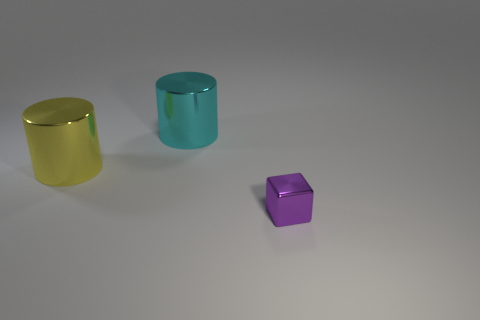The purple metallic block is what size?
Give a very brief answer. Small. There is a object that is on the right side of the cyan thing; what shape is it?
Make the answer very short. Cube. Do the big cyan metal thing and the yellow metallic thing have the same shape?
Offer a terse response. Yes. Is the number of purple objects that are behind the big yellow cylinder the same as the number of large blue matte blocks?
Your answer should be very brief. Yes. What is the shape of the small metal object?
Provide a succinct answer. Cube. There is a metallic cylinder that is to the right of the yellow metallic cylinder; does it have the same size as the shiny cylinder in front of the cyan metallic object?
Ensure brevity in your answer.  Yes. What is the shape of the big thing in front of the metal cylinder right of the large yellow shiny cylinder?
Your answer should be very brief. Cylinder. Is the size of the cyan thing the same as the metal cylinder in front of the cyan object?
Your response must be concise. Yes. There is a yellow metallic cylinder in front of the metal cylinder to the right of the shiny cylinder that is on the left side of the large cyan metal thing; how big is it?
Offer a terse response. Large. How many objects are either metallic objects behind the small object or purple metallic objects?
Your response must be concise. 3. 